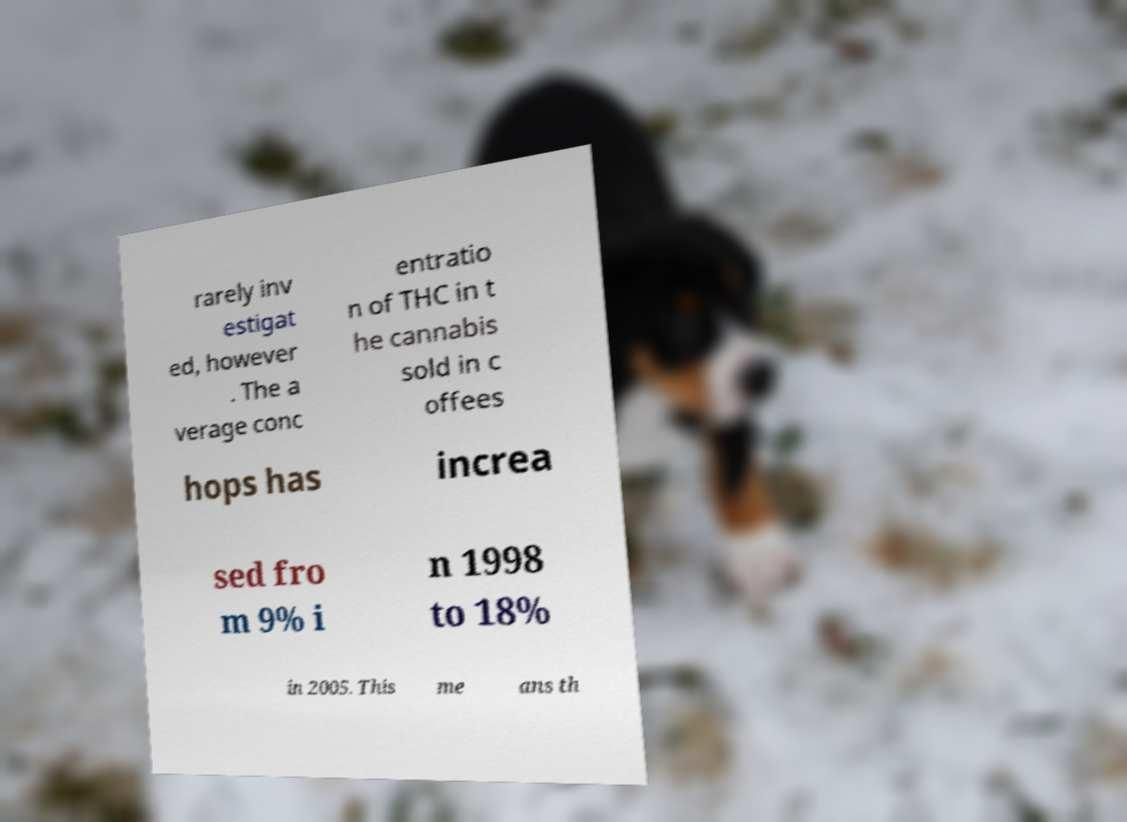Could you assist in decoding the text presented in this image and type it out clearly? rarely inv estigat ed, however . The a verage conc entratio n of THC in t he cannabis sold in c offees hops has increa sed fro m 9% i n 1998 to 18% in 2005. This me ans th 